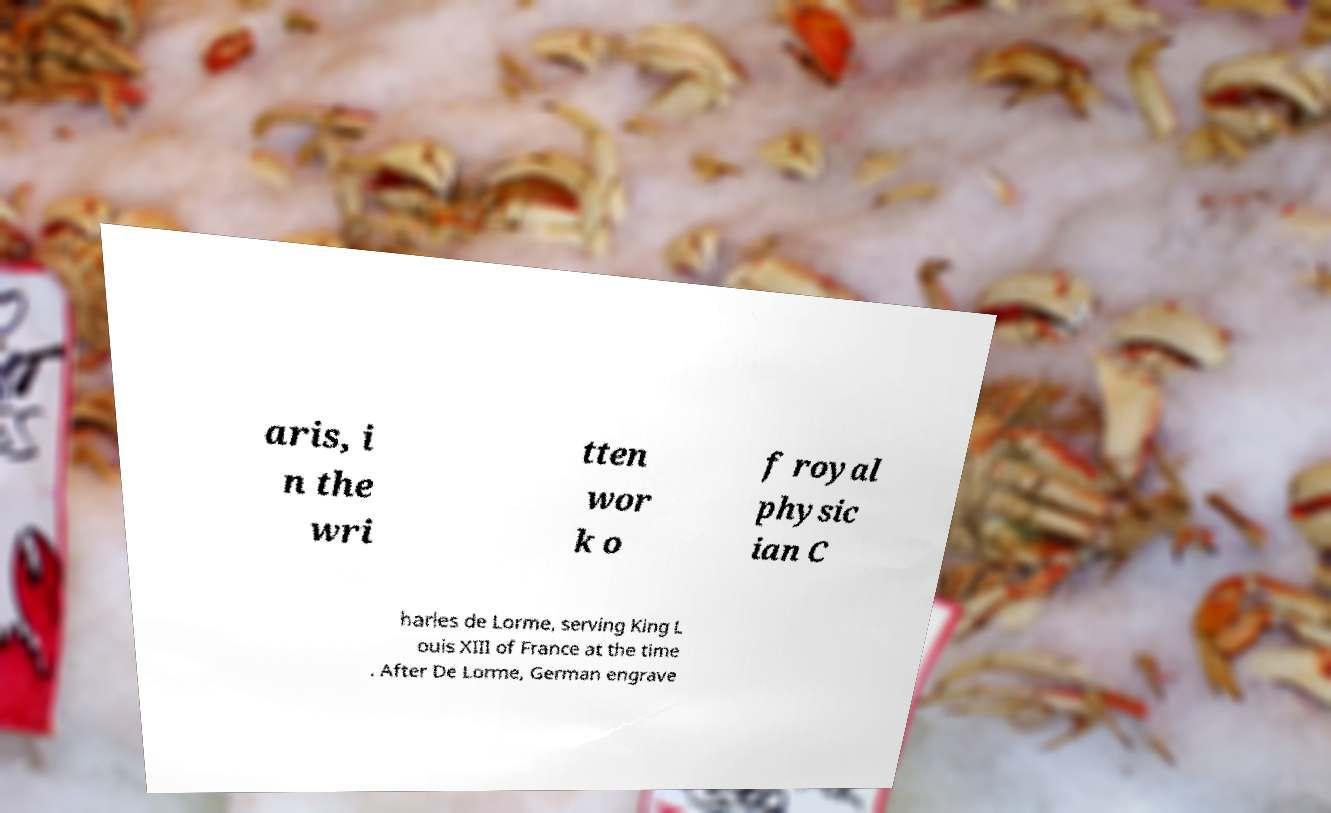Please read and relay the text visible in this image. What does it say? aris, i n the wri tten wor k o f royal physic ian C harles de Lorme, serving King L ouis XIII of France at the time . After De Lorme, German engrave 